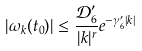<formula> <loc_0><loc_0><loc_500><loc_500>| \omega _ { k } ( t _ { 0 } ) | \leq \frac { \mathcal { D } _ { 6 } ^ { \prime } } { | k | ^ { r } } e ^ { - \gamma _ { 6 } ^ { \prime } | k | }</formula> 